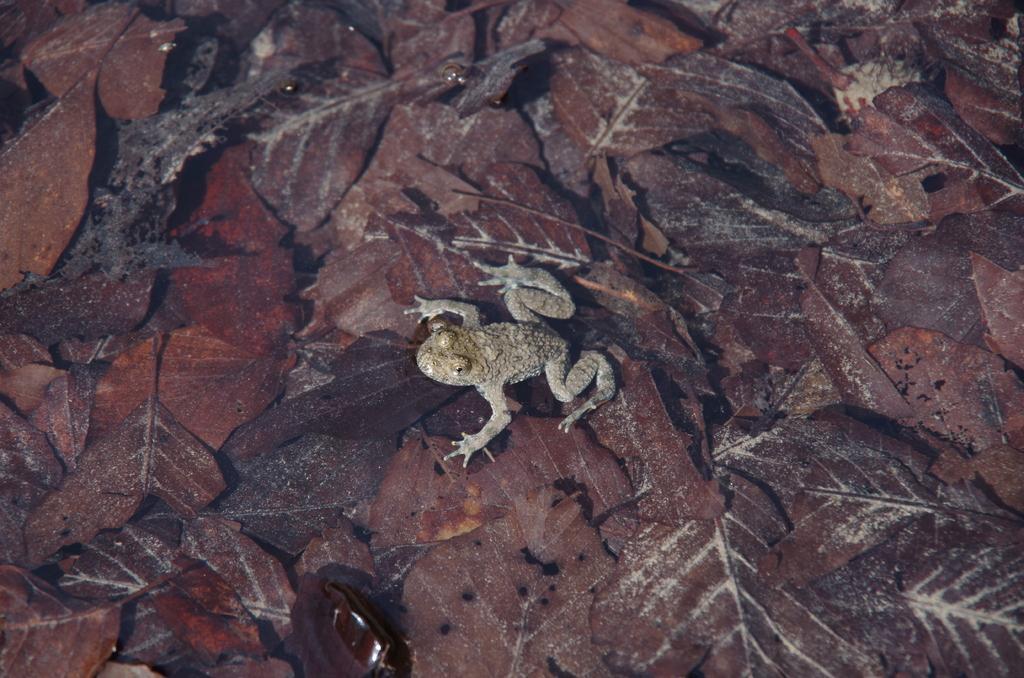Please provide a concise description of this image. In this image there is a frog on leaves. 